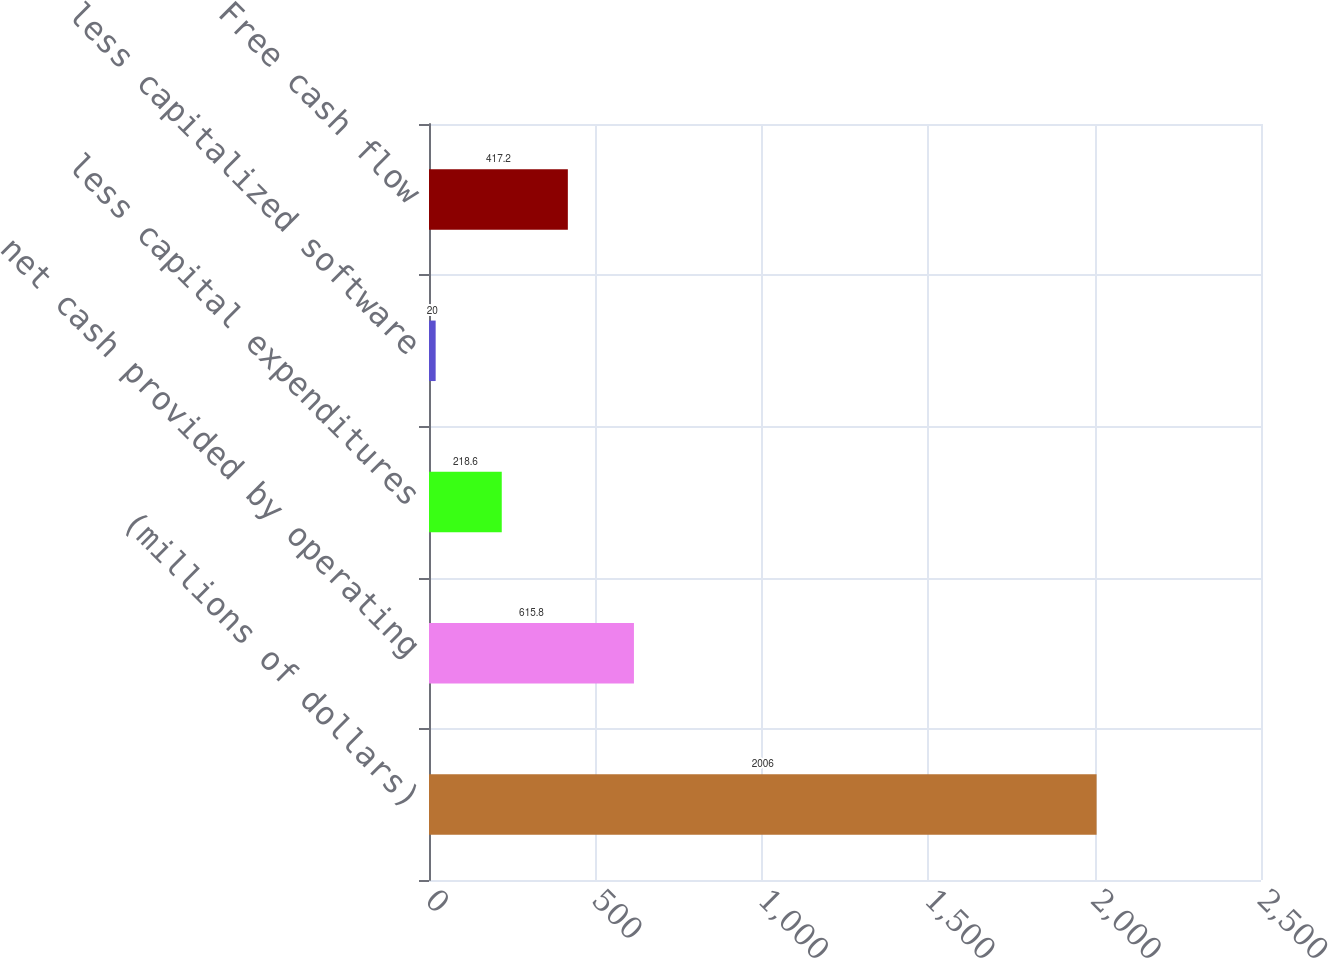Convert chart to OTSL. <chart><loc_0><loc_0><loc_500><loc_500><bar_chart><fcel>(millions of dollars)<fcel>net cash provided by operating<fcel>less capital expenditures<fcel>less capitalized software<fcel>Free cash flow<nl><fcel>2006<fcel>615.8<fcel>218.6<fcel>20<fcel>417.2<nl></chart> 